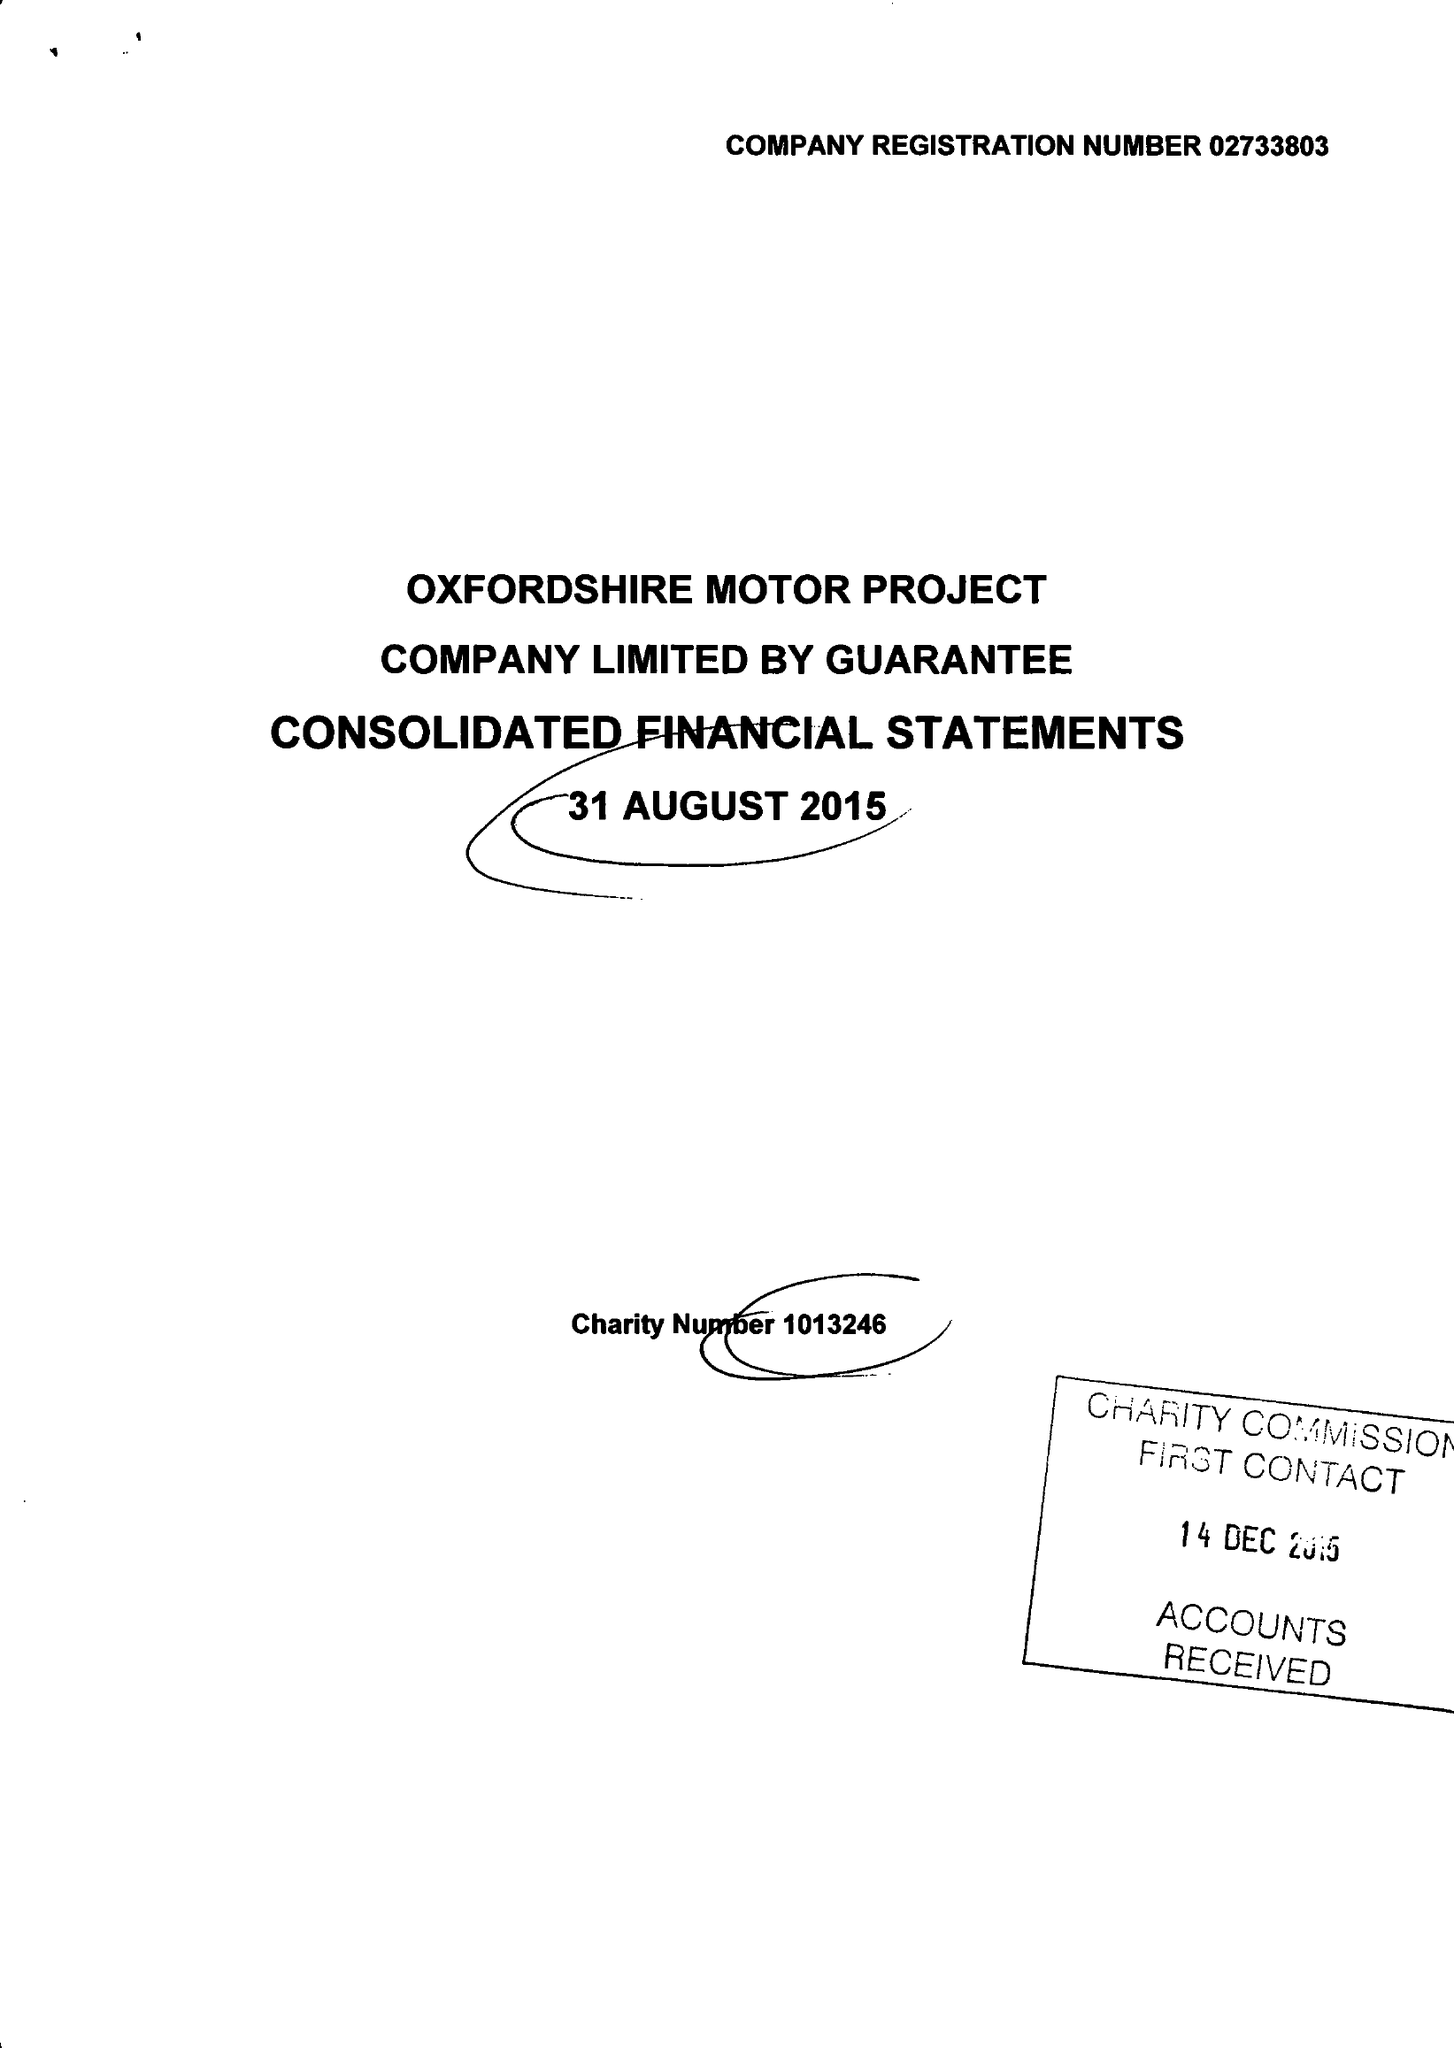What is the value for the charity_name?
Answer the question using a single word or phrase. Oxfordshire Motor Project 